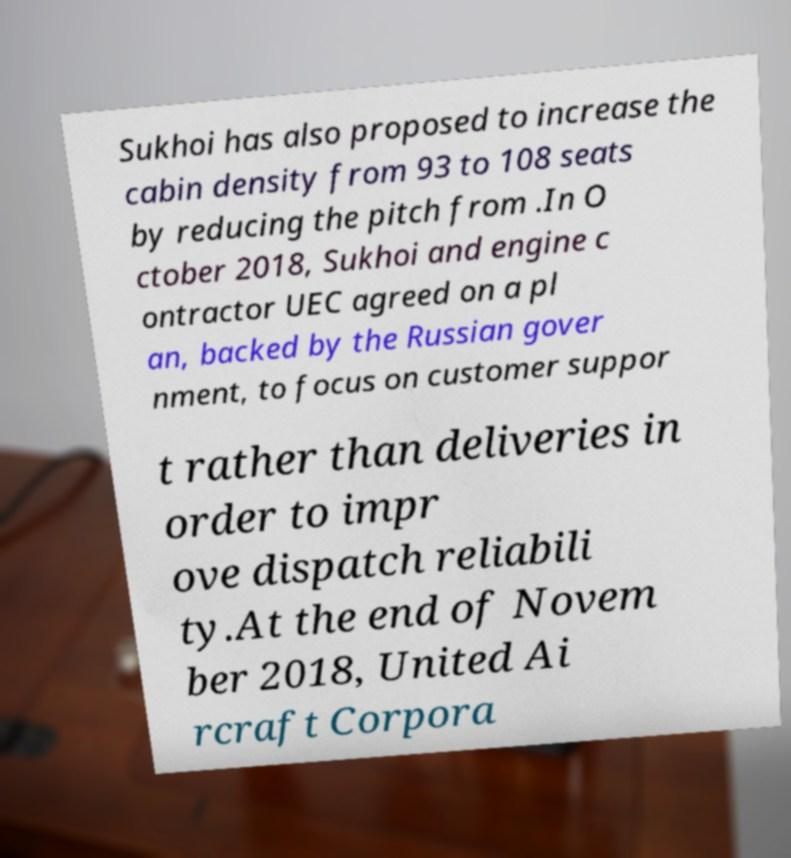Can you accurately transcribe the text from the provided image for me? Sukhoi has also proposed to increase the cabin density from 93 to 108 seats by reducing the pitch from .In O ctober 2018, Sukhoi and engine c ontractor UEC agreed on a pl an, backed by the Russian gover nment, to focus on customer suppor t rather than deliveries in order to impr ove dispatch reliabili ty.At the end of Novem ber 2018, United Ai rcraft Corpora 